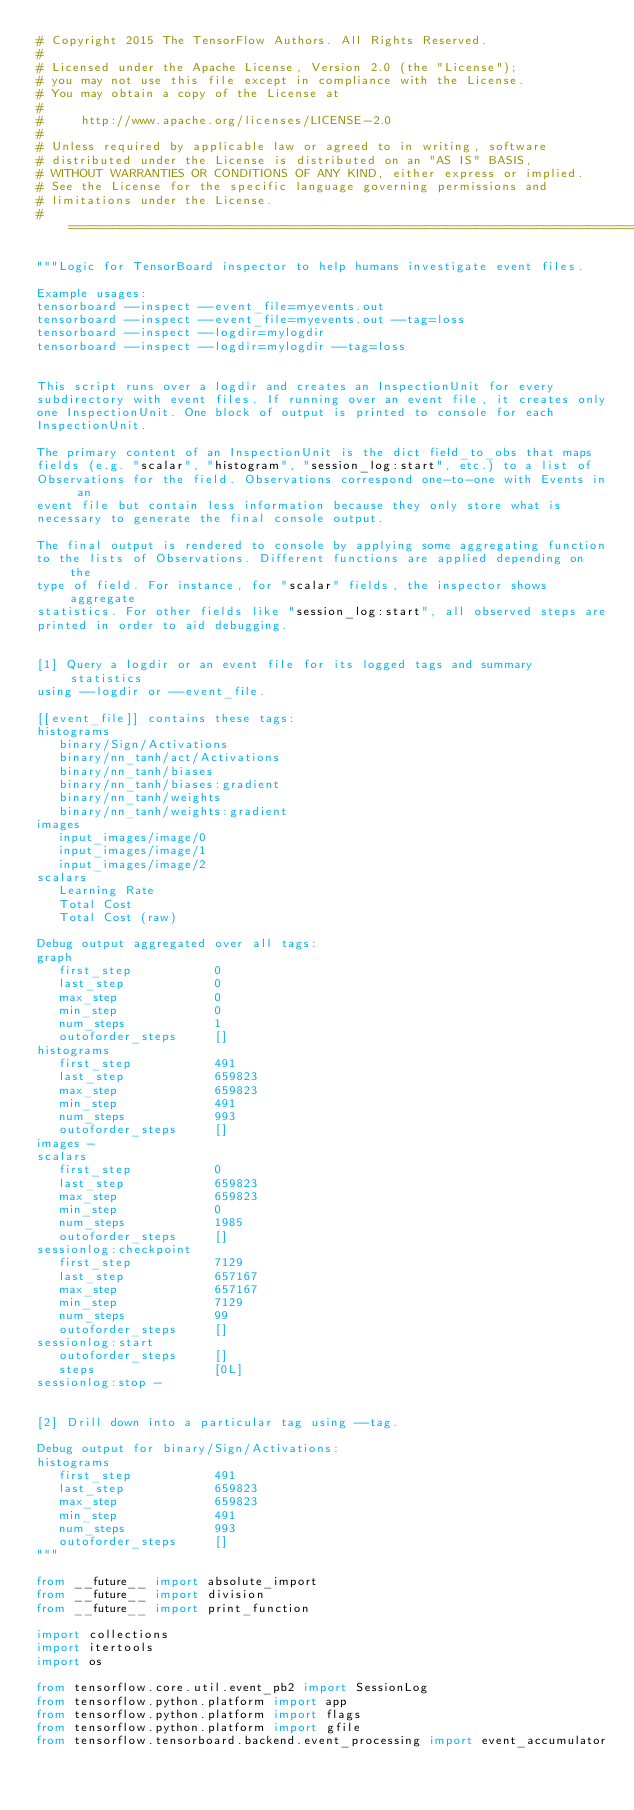<code> <loc_0><loc_0><loc_500><loc_500><_Python_># Copyright 2015 The TensorFlow Authors. All Rights Reserved.
#
# Licensed under the Apache License, Version 2.0 (the "License");
# you may not use this file except in compliance with the License.
# You may obtain a copy of the License at
#
#     http://www.apache.org/licenses/LICENSE-2.0
#
# Unless required by applicable law or agreed to in writing, software
# distributed under the License is distributed on an "AS IS" BASIS,
# WITHOUT WARRANTIES OR CONDITIONS OF ANY KIND, either express or implied.
# See the License for the specific language governing permissions and
# limitations under the License.
# ==============================================================================

"""Logic for TensorBoard inspector to help humans investigate event files.

Example usages:
tensorboard --inspect --event_file=myevents.out
tensorboard --inspect --event_file=myevents.out --tag=loss
tensorboard --inspect --logdir=mylogdir
tensorboard --inspect --logdir=mylogdir --tag=loss


This script runs over a logdir and creates an InspectionUnit for every
subdirectory with event files. If running over an event file, it creates only
one InspectionUnit. One block of output is printed to console for each
InspectionUnit.

The primary content of an InspectionUnit is the dict field_to_obs that maps
fields (e.g. "scalar", "histogram", "session_log:start", etc.) to a list of
Observations for the field. Observations correspond one-to-one with Events in an
event file but contain less information because they only store what is
necessary to generate the final console output.

The final output is rendered to console by applying some aggregating function
to the lists of Observations. Different functions are applied depending on the
type of field. For instance, for "scalar" fields, the inspector shows aggregate
statistics. For other fields like "session_log:start", all observed steps are
printed in order to aid debugging.


[1] Query a logdir or an event file for its logged tags and summary statistics
using --logdir or --event_file.

[[event_file]] contains these tags:
histograms
   binary/Sign/Activations
   binary/nn_tanh/act/Activations
   binary/nn_tanh/biases
   binary/nn_tanh/biases:gradient
   binary/nn_tanh/weights
   binary/nn_tanh/weights:gradient
images
   input_images/image/0
   input_images/image/1
   input_images/image/2
scalars
   Learning Rate
   Total Cost
   Total Cost (raw)

Debug output aggregated over all tags:
graph
   first_step           0
   last_step            0
   max_step             0
   min_step             0
   num_steps            1
   outoforder_steps     []
histograms
   first_step           491
   last_step            659823
   max_step             659823
   min_step             491
   num_steps            993
   outoforder_steps     []
images -
scalars
   first_step           0
   last_step            659823
   max_step             659823
   min_step             0
   num_steps            1985
   outoforder_steps     []
sessionlog:checkpoint
   first_step           7129
   last_step            657167
   max_step             657167
   min_step             7129
   num_steps            99
   outoforder_steps     []
sessionlog:start
   outoforder_steps     []
   steps                [0L]
sessionlog:stop -


[2] Drill down into a particular tag using --tag.

Debug output for binary/Sign/Activations:
histograms
   first_step           491
   last_step            659823
   max_step             659823
   min_step             491
   num_steps            993
   outoforder_steps     []
"""

from __future__ import absolute_import
from __future__ import division
from __future__ import print_function

import collections
import itertools
import os

from tensorflow.core.util.event_pb2 import SessionLog
from tensorflow.python.platform import app
from tensorflow.python.platform import flags
from tensorflow.python.platform import gfile
from tensorflow.tensorboard.backend.event_processing import event_accumulator</code> 